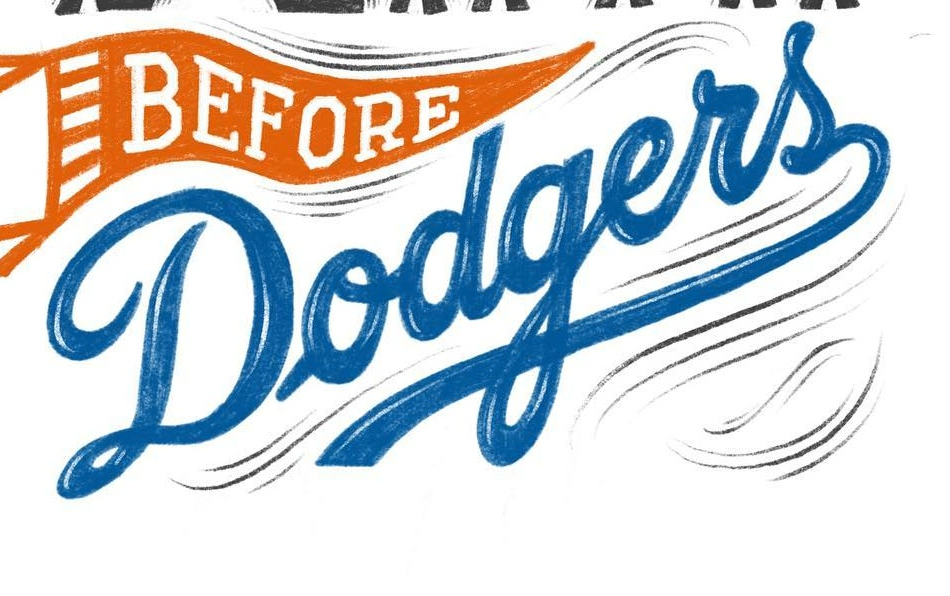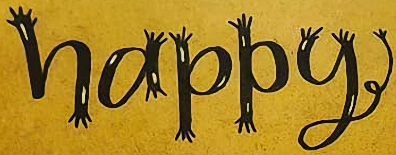Transcribe the words shown in these images in order, separated by a semicolon. Dodgers; happy 